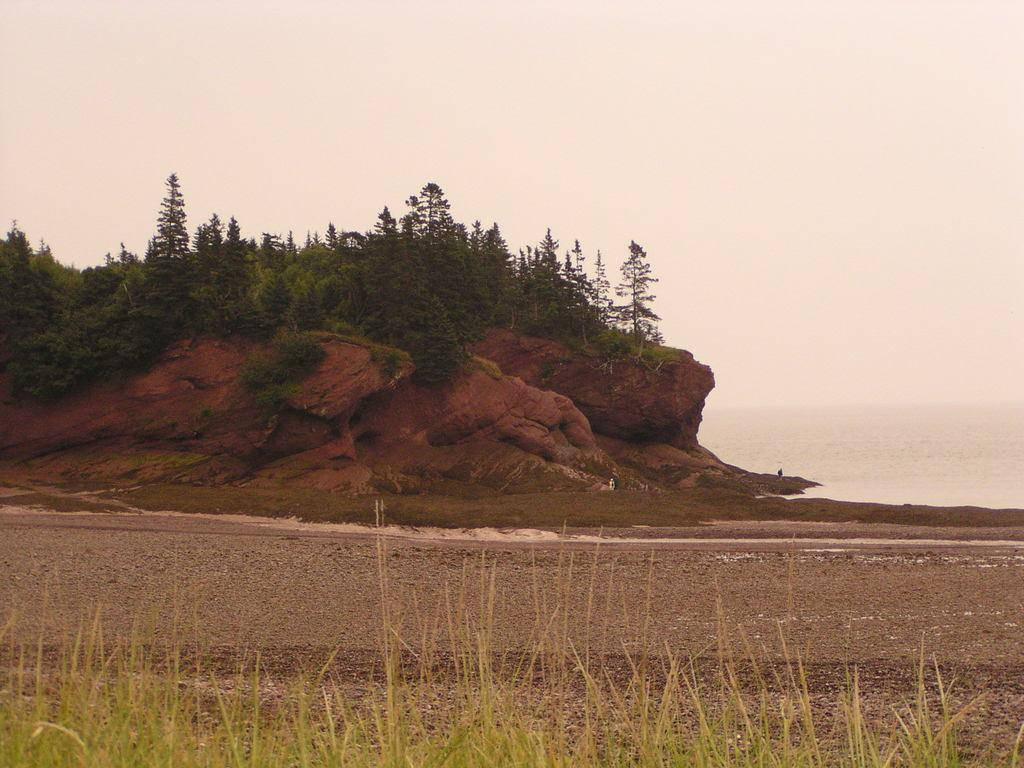What is the main feature in the image? There is a big rock in the image. What is growing on the rock? There are plants on the rock. What type of terrain is visible at the bottom of the image? There is sand at the bottom of the image. What type of vegetation is present on the sand? There is grass on the sand. What can be seen in the sky in the image? The sky is visible at the top of the image. What time is displayed on the alarm clock in the image? There is no alarm clock present in the image. What type of pump is used to water the plants on the rock? There is no pump visible in the image; the plants appear to be growing naturally on the rock. 